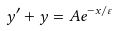Convert formula to latex. <formula><loc_0><loc_0><loc_500><loc_500>y ^ { \prime } + y = A e ^ { - x / \varepsilon }</formula> 